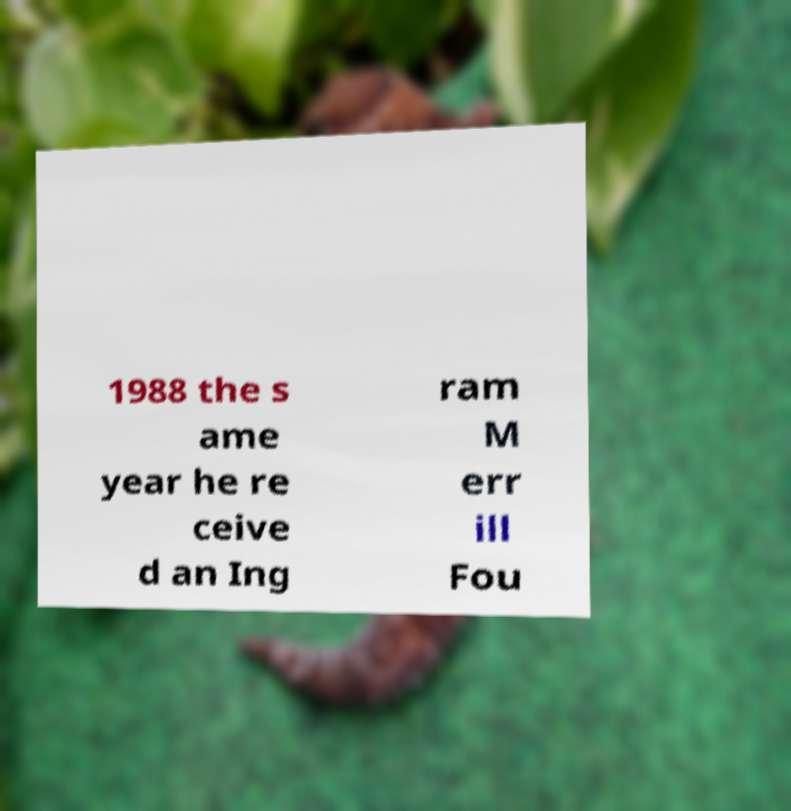What messages or text are displayed in this image? I need them in a readable, typed format. 1988 the s ame year he re ceive d an Ing ram M err ill Fou 